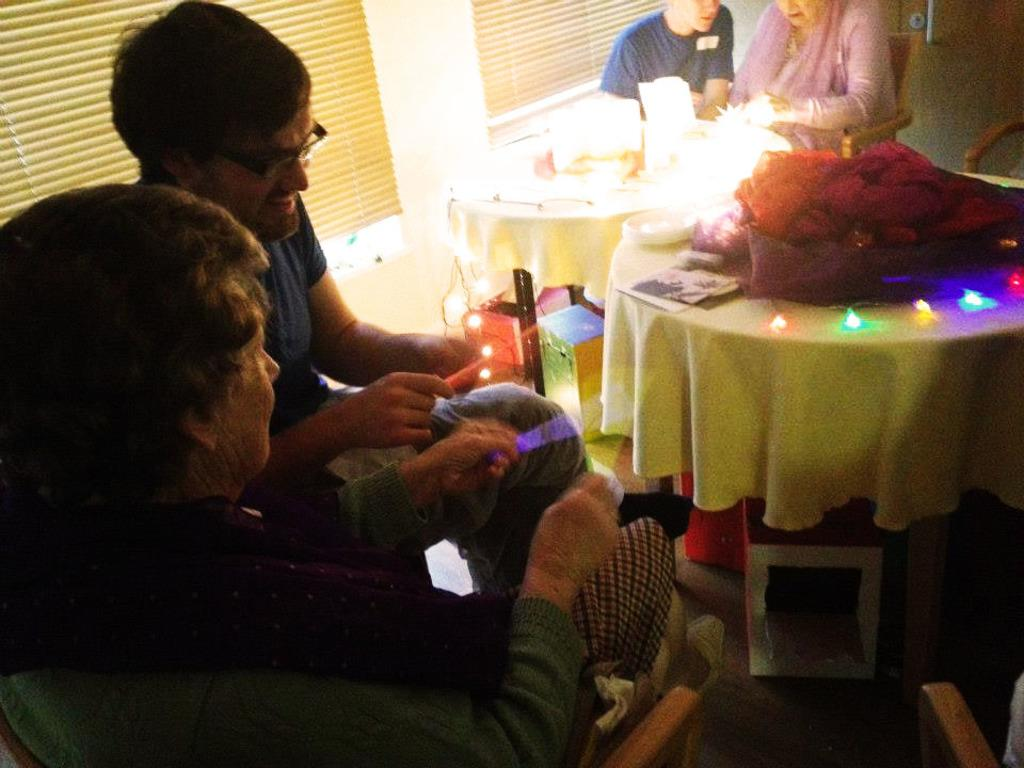How many people are in the image? There are four persons in the image. How are the people arranged in relation to the chair? Two persons are sitting on one side of the chair, and two persons are sitting on the other side of the chair. What furniture is present in the image? There is a chair and two tables in the image. What can be found on the tables? Different items are present on the tables. What type of scarf is draped over the lamp in the image? There is no scarf or lamp present in the image. What type of office setting is depicted in the image? The image does not depict an office setting; it features a chair and two tables with people sitting around them. 